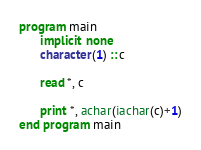Convert code to text. <code><loc_0><loc_0><loc_500><loc_500><_FORTRAN_>program main
      implicit none
      character(1) :: c

      read *, c

      print *, achar(iachar(c)+1)
end program main
</code> 